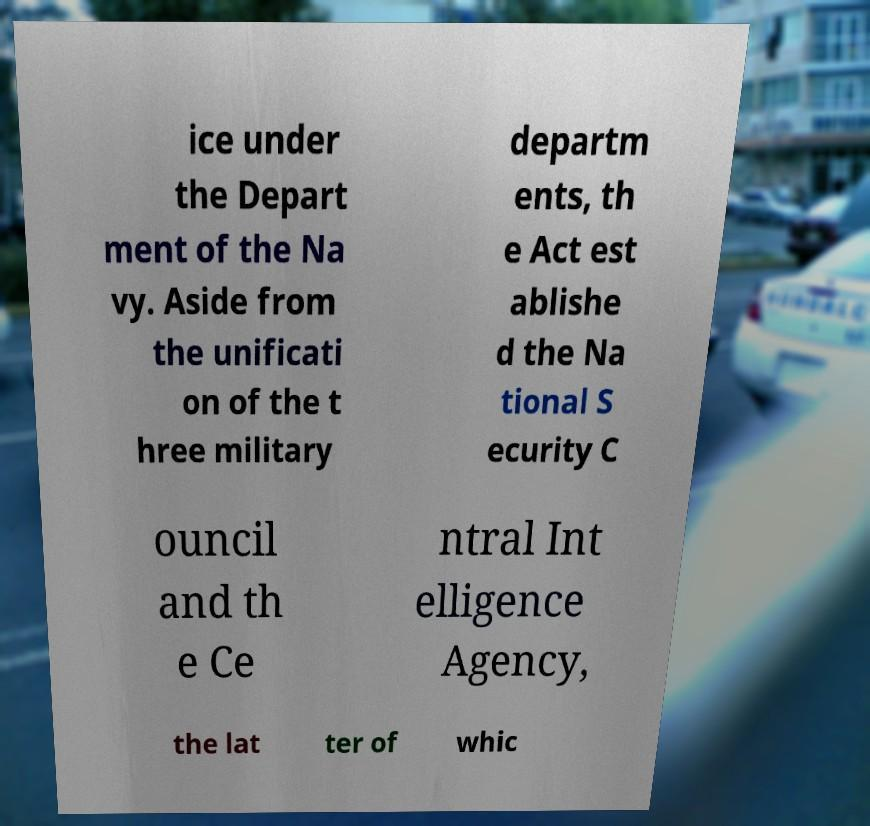Could you extract and type out the text from this image? ice under the Depart ment of the Na vy. Aside from the unificati on of the t hree military departm ents, th e Act est ablishe d the Na tional S ecurity C ouncil and th e Ce ntral Int elligence Agency, the lat ter of whic 